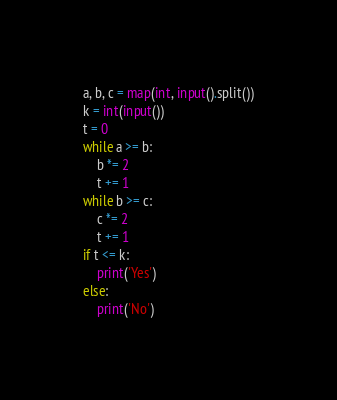<code> <loc_0><loc_0><loc_500><loc_500><_Python_>a, b, c = map(int, input().split())
k = int(input())
t = 0
while a >= b:
    b *= 2
    t += 1
while b >= c:
    c *= 2
    t += 1
if t <= k:
    print('Yes')
else:
    print('No')
</code> 